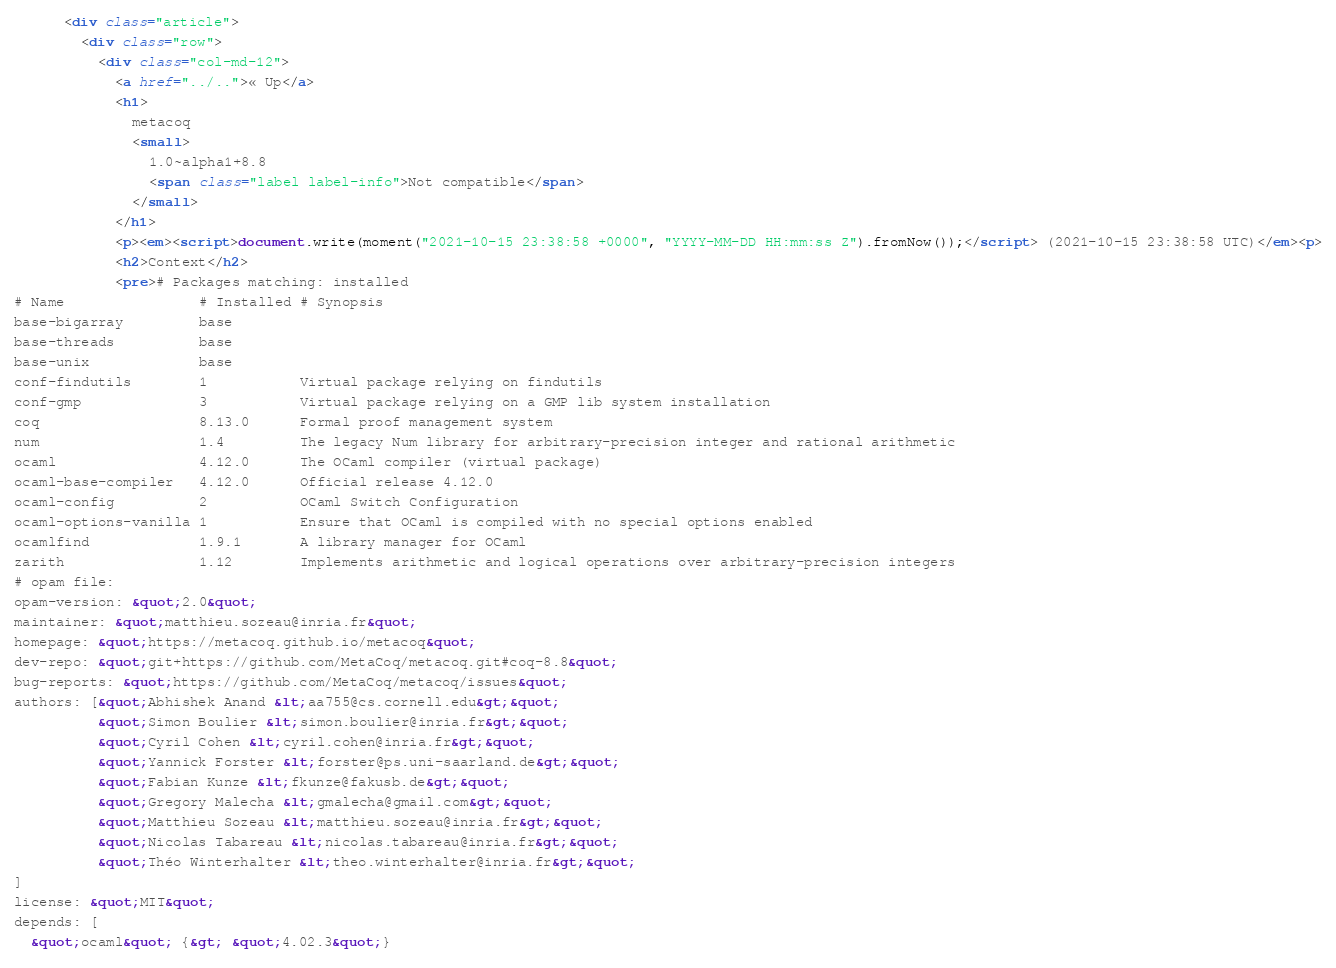Convert code to text. <code><loc_0><loc_0><loc_500><loc_500><_HTML_>      <div class="article">
        <div class="row">
          <div class="col-md-12">
            <a href="../..">« Up</a>
            <h1>
              metacoq
              <small>
                1.0~alpha1+8.8
                <span class="label label-info">Not compatible</span>
              </small>
            </h1>
            <p><em><script>document.write(moment("2021-10-15 23:38:58 +0000", "YYYY-MM-DD HH:mm:ss Z").fromNow());</script> (2021-10-15 23:38:58 UTC)</em><p>
            <h2>Context</h2>
            <pre># Packages matching: installed
# Name                # Installed # Synopsis
base-bigarray         base
base-threads          base
base-unix             base
conf-findutils        1           Virtual package relying on findutils
conf-gmp              3           Virtual package relying on a GMP lib system installation
coq                   8.13.0      Formal proof management system
num                   1.4         The legacy Num library for arbitrary-precision integer and rational arithmetic
ocaml                 4.12.0      The OCaml compiler (virtual package)
ocaml-base-compiler   4.12.0      Official release 4.12.0
ocaml-config          2           OCaml Switch Configuration
ocaml-options-vanilla 1           Ensure that OCaml is compiled with no special options enabled
ocamlfind             1.9.1       A library manager for OCaml
zarith                1.12        Implements arithmetic and logical operations over arbitrary-precision integers
# opam file:
opam-version: &quot;2.0&quot;
maintainer: &quot;matthieu.sozeau@inria.fr&quot;
homepage: &quot;https://metacoq.github.io/metacoq&quot;
dev-repo: &quot;git+https://github.com/MetaCoq/metacoq.git#coq-8.8&quot;
bug-reports: &quot;https://github.com/MetaCoq/metacoq/issues&quot;
authors: [&quot;Abhishek Anand &lt;aa755@cs.cornell.edu&gt;&quot;
          &quot;Simon Boulier &lt;simon.boulier@inria.fr&gt;&quot;
          &quot;Cyril Cohen &lt;cyril.cohen@inria.fr&gt;&quot;
          &quot;Yannick Forster &lt;forster@ps.uni-saarland.de&gt;&quot;
          &quot;Fabian Kunze &lt;fkunze@fakusb.de&gt;&quot;
          &quot;Gregory Malecha &lt;gmalecha@gmail.com&gt;&quot;
          &quot;Matthieu Sozeau &lt;matthieu.sozeau@inria.fr&gt;&quot;
          &quot;Nicolas Tabareau &lt;nicolas.tabareau@inria.fr&gt;&quot;
          &quot;Théo Winterhalter &lt;theo.winterhalter@inria.fr&gt;&quot;
]
license: &quot;MIT&quot;
depends: [
  &quot;ocaml&quot; {&gt; &quot;4.02.3&quot;}</code> 